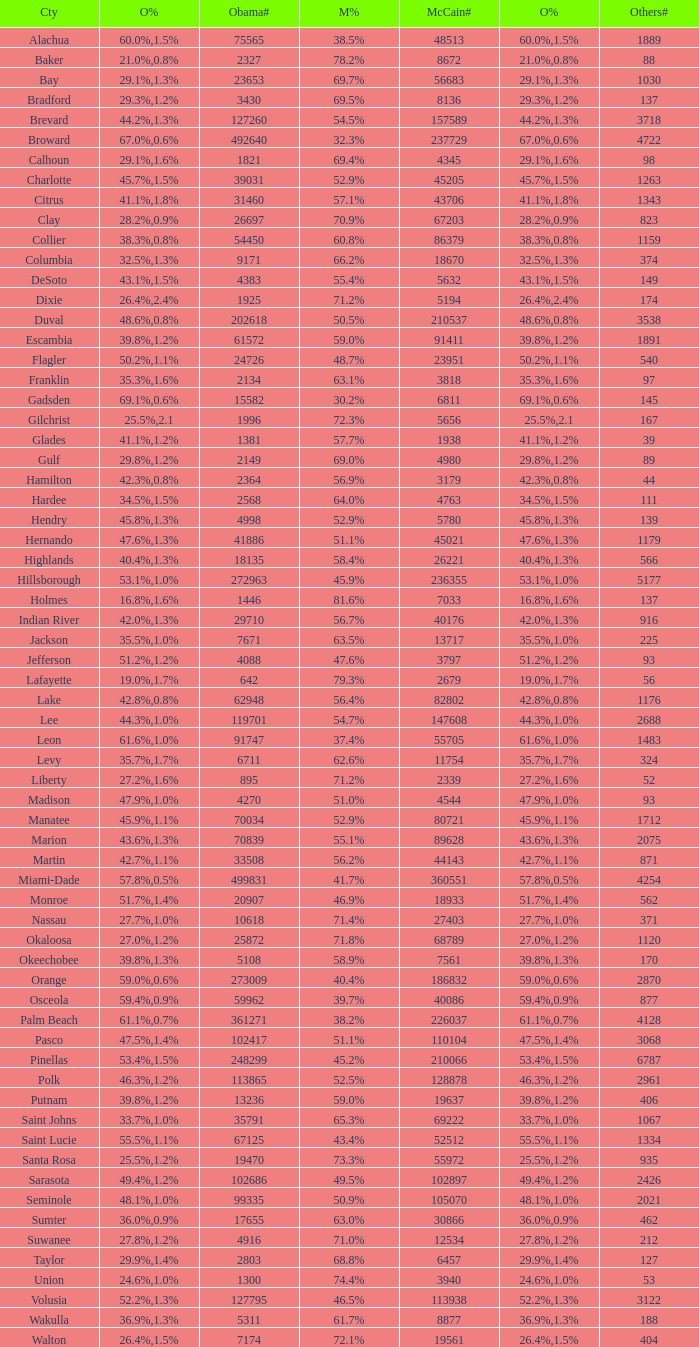What percentage was the others vote when McCain had 52.9% and less than 45205.0 voters? 1.3%. 